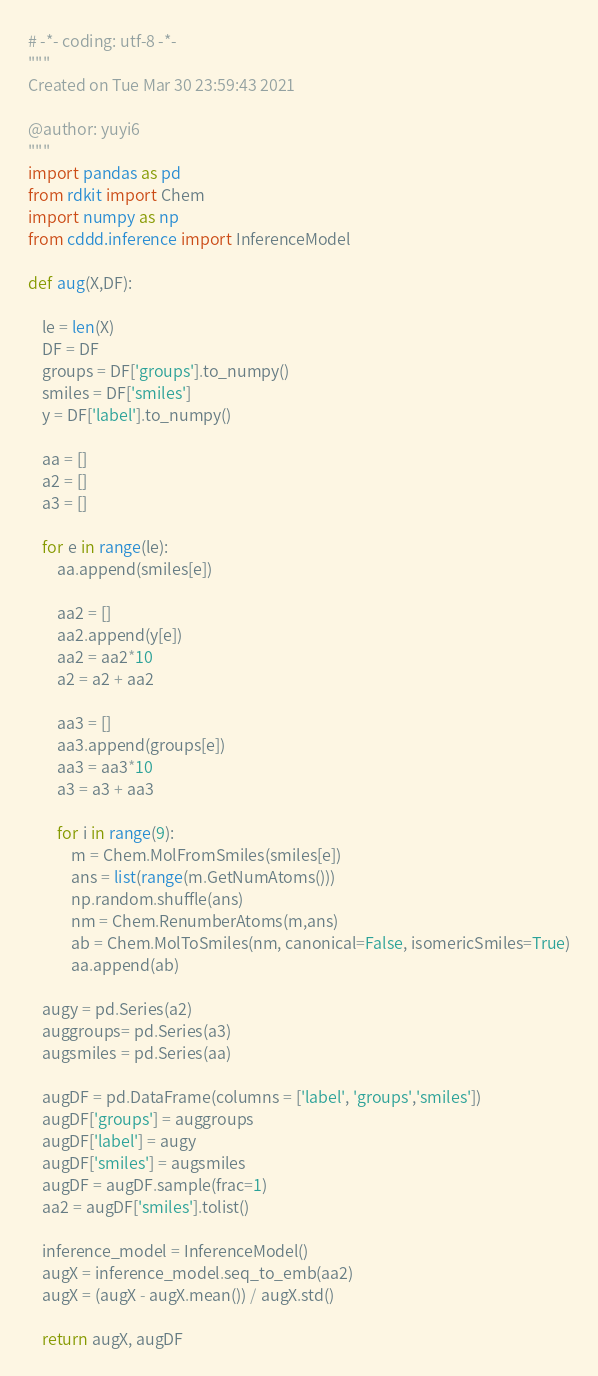<code> <loc_0><loc_0><loc_500><loc_500><_Python_># -*- coding: utf-8 -*-
"""
Created on Tue Mar 30 23:59:43 2021

@author: yuyi6
"""
import pandas as pd
from rdkit import Chem
import numpy as np
from cddd.inference import InferenceModel

def aug(X,DF):

    le = len(X)
    DF = DF 
    groups = DF['groups'].to_numpy()
    smiles = DF['smiles']
    y = DF['label'].to_numpy()
    
    aa = []
    a2 = []
    a3 = []
    
    for e in range(le):
        aa.append(smiles[e])
        
        aa2 = []
        aa2.append(y[e])
        aa2 = aa2*10
        a2 = a2 + aa2
        
        aa3 = []
        aa3.append(groups[e])
        aa3 = aa3*10
        a3 = a3 + aa3
        
        for i in range(9):
            m = Chem.MolFromSmiles(smiles[e])
            ans = list(range(m.GetNumAtoms()))
            np.random.shuffle(ans)
            nm = Chem.RenumberAtoms(m,ans)
            ab = Chem.MolToSmiles(nm, canonical=False, isomericSmiles=True)
            aa.append(ab)
    
    augy = pd.Series(a2)
    auggroups= pd.Series(a3)
    augsmiles = pd.Series(aa)
    
    augDF = pd.DataFrame(columns = ['label', 'groups','smiles'])
    augDF['groups'] = auggroups
    augDF['label'] = augy
    augDF['smiles'] = augsmiles
    augDF = augDF.sample(frac=1)
    aa2 = augDF['smiles'].tolist()
    
    inference_model = InferenceModel()
    augX = inference_model.seq_to_emb(aa2)
    augX = (augX - augX.mean()) / augX.std()

    return augX, augDF

</code> 